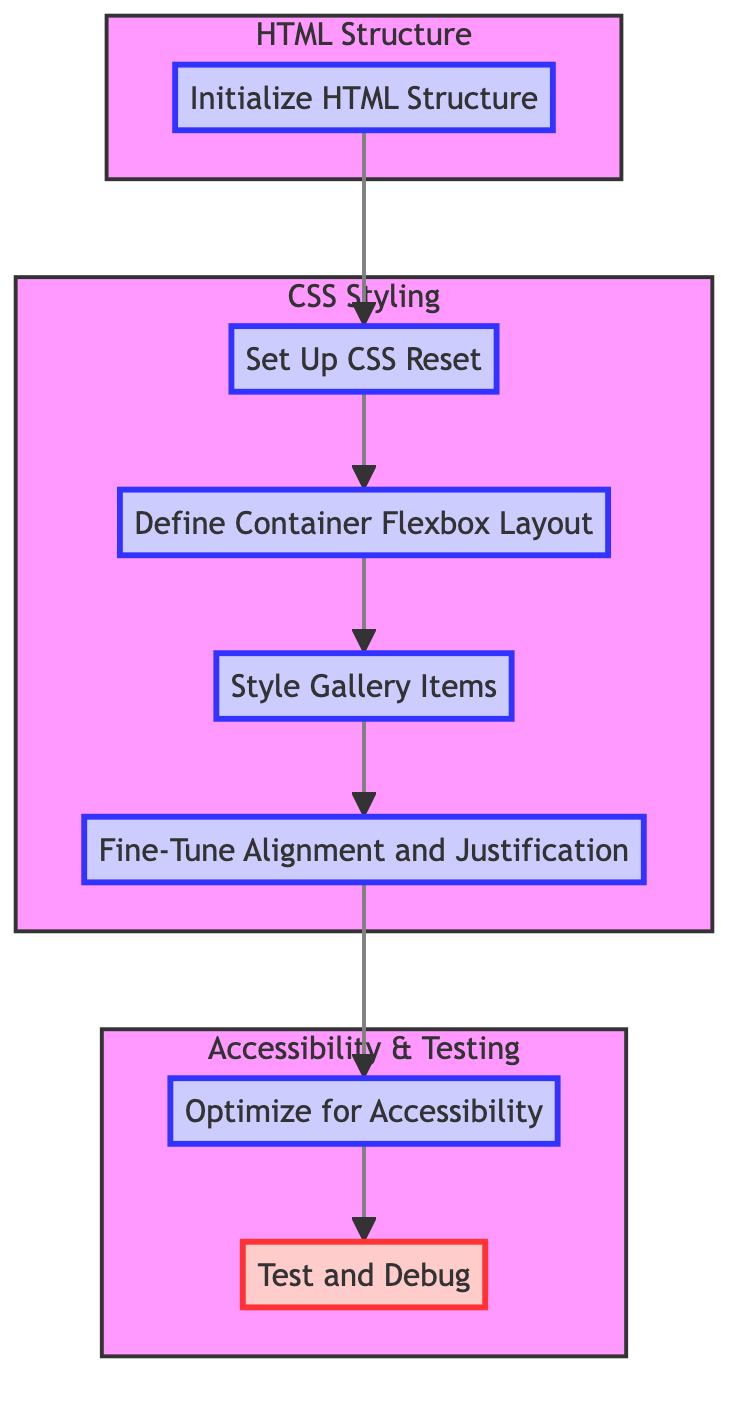What is the total number of steps in the flowchart? The flowchart contains seven distinct steps, as indicated by the nodes connecting from one to the next.
Answer: 7 Which step follows "Define Container Flexbox Layout"? The next step that follows "Define Container Flexbox Layout" is "Style Gallery Items," as indicated by the direct arrow connecting them in the flow diagram.
Answer: Style Gallery Items What subgraph does the "Optimize for Accessibility" step belong to? The "Optimize for Accessibility" step is part of the "Accessibility & Testing" subgraph, which encompasses the final two steps in the layout.
Answer: Accessibility & Testing What alignment property is suggested for the items to fill the container height? The suggested alignment property to ensure items expand to fill the container height is "stretch," as indicated in the "Fine-Tune Alignment and Justification" step.
Answer: stretch How many elements are in the 'CSS Styling' subgraph? The 'CSS Styling' subgraph contains four elements, which can be counted as the steps related to CSS styling in the flowchart.
Answer: 4 Which step comes before the "Test and Debug" step? The step that comes immediately before "Test and Debug" is "Optimize for Accessibility," as shown by the connection in the flow diagram.
Answer: Optimize for Accessibility What type of relationship exists between the "Set Up CSS Reset" step and the "Define Container Flexbox Layout" step? The relationship is sequential, with "Set Up CSS Reset" leading directly to "Define Container Flexbox Layout," indicating a step-by-step progression in the design process.
Answer: sequential What color indicates the emphasis in the last step of the flowchart? The last step "Test and Debug" is indicated by a fill color of pink, which designates it as an emphasis step according to the diagram's styling rules.
Answer: pink 